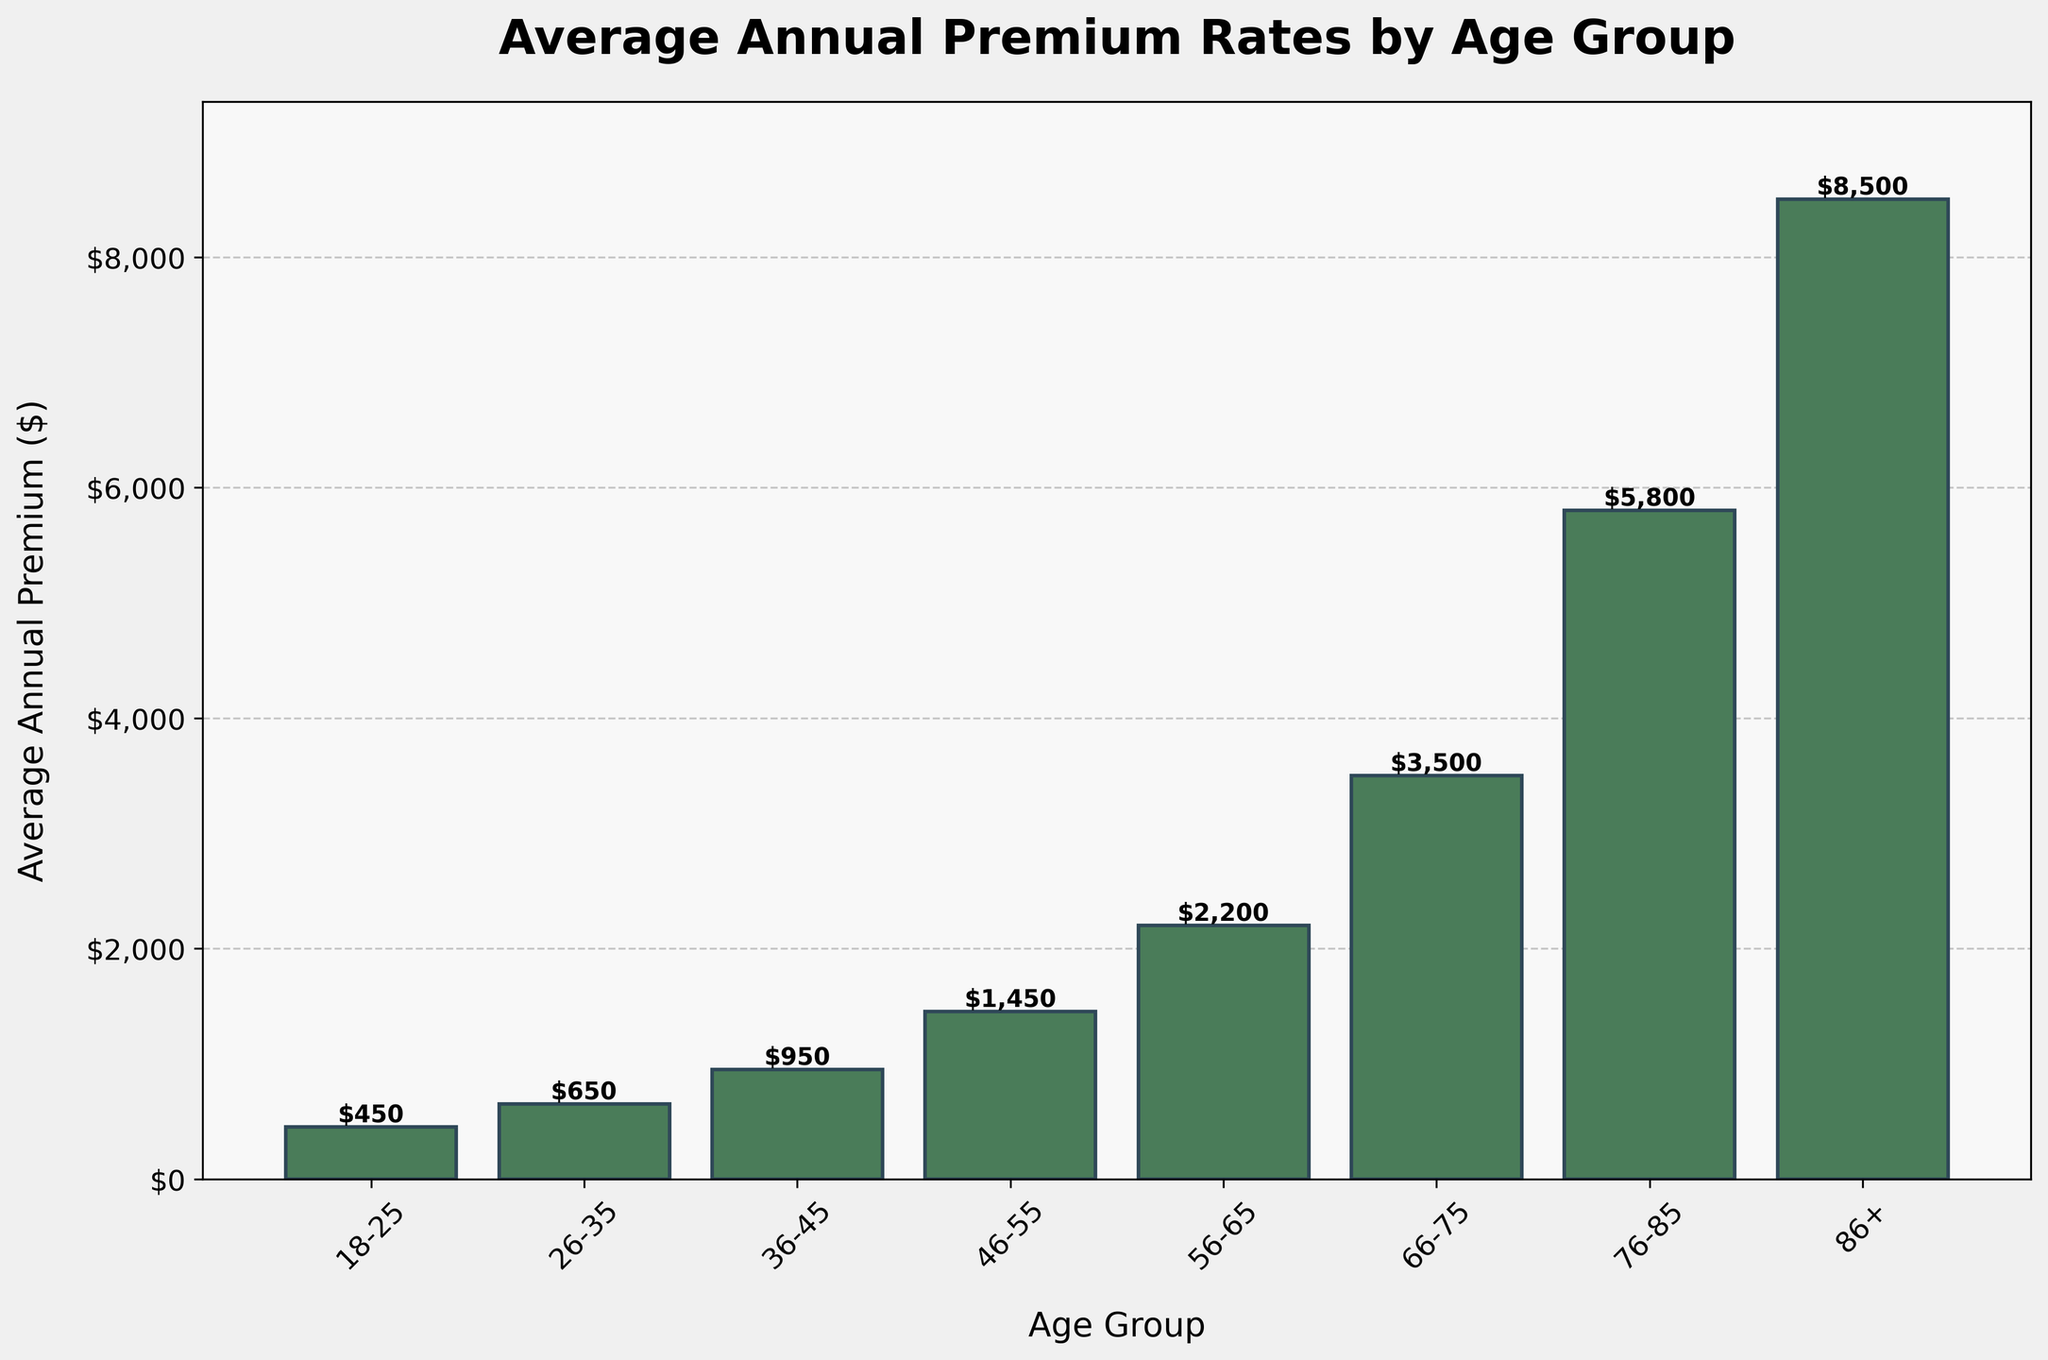What's the average premium of the first three age groups? To calculate the average premium of the 18-25, 26-35, and 36-45 age groups, sum their premiums and divide by 3: (450 + 650 + 950) / 3 = 2050 / 3 = 683.33
Answer: 683.33 How does the premium for the 56-65 age group compare to the 46-55 age group? The premium for the 56-65 age group is $2200, and the premium for the 46-55 age group is $1450. To compare, subtract the premium of the 46-55 age group from the 56-65 age group: 2200 - 1450 = 750. The premium for the 56-65 age group is $750 higher.
Answer: 750 higher Which age group has the highest average annual premium? The age group with the highest average annual premium is the 86+ group, with a premium of $8500.
Answer: 86+ By how much does the premium increase from the 66-75 group to the 76-85 group? The premium for the 66-75 group is $3500, and for the 76-85 group, it is $5800. To find the increase: 5800 - 3500 = 2300. The premium increases by $2300.
Answer: 2300 What is the premium difference between the youngest and oldest age groups? The premium for the youngest age group (18-25) is $450, and for the oldest age group (86+) it is $8500. To find the difference: 8500 - 450 = 8050. The difference is $8050.
Answer: 8050 What is the sum of premiums for the age groups 18-25, 46-55, and 76-85? Sum the premiums for the age groups 18-25 ($450), 46-55 ($1450), and 76-85 ($5800): 450 + 1450 + 5800 = 7700. The sum is $7700.
Answer: 7700 How does the average premium for age groups under 45 compare to those 45 and above? Calculate the average for each group. Under 45: (450 + 650 + 950) / 3 = 683.33. 45 and above: (1450 + 2200 + 3500 + 5800 + 8500) / 5 = 4290. Reading the plotted data, the premiums increase.
Answer: Under 45: 683.33, 45 and above: 4290 Which age group has a premium closest to $2000? The age group with a premium closest to $2000 is the 56-65 group with a premium of $2200.
Answer: 56-65 What's the height of the bars for the 36-45 and 86+ age groups compared to each other? The height of the bar for the 36-45 age group is $950, and for the 86+ age group is $8500. The 86+ age group bar is higher by $7550 compared to the 36-45 group.
Answer: 86+ bar higher by $7550 